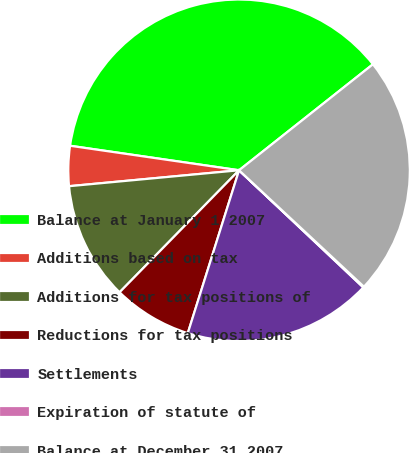Convert chart. <chart><loc_0><loc_0><loc_500><loc_500><pie_chart><fcel>Balance at January 1 2007<fcel>Additions based on tax<fcel>Additions for tax positions of<fcel>Reductions for tax positions<fcel>Settlements<fcel>Expiration of statute of<fcel>Balance at December 31 2007<nl><fcel>37.05%<fcel>3.78%<fcel>11.18%<fcel>7.48%<fcel>17.82%<fcel>0.09%<fcel>22.6%<nl></chart> 